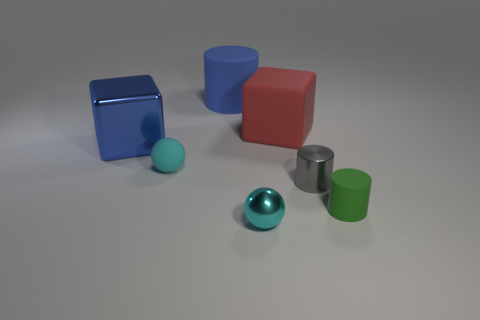Do the block behind the large metal block and the tiny green cylinder have the same material?
Your answer should be compact. Yes. Are there any large things that have the same color as the rubber cube?
Your answer should be compact. No. Are there any green metallic cylinders?
Ensure brevity in your answer.  No. There is a matte object that is right of the gray metal cylinder; is its size the same as the gray metallic thing?
Provide a succinct answer. Yes. Are there fewer tiny rubber cylinders than large cyan objects?
Offer a terse response. No. There is a blue thing left of the blue object that is to the right of the cyan thing that is behind the tiny green matte cylinder; what shape is it?
Make the answer very short. Cube. Are there any large blue cylinders made of the same material as the gray object?
Make the answer very short. No. Does the small shiny cylinder in front of the cyan rubber thing have the same color as the metallic ball in front of the big cylinder?
Make the answer very short. No. Are there fewer blue shiny blocks behind the large blue cylinder than blue matte cubes?
Make the answer very short. No. How many objects are either large red blocks or large red matte blocks on the right side of the tiny cyan metallic object?
Give a very brief answer. 1. 